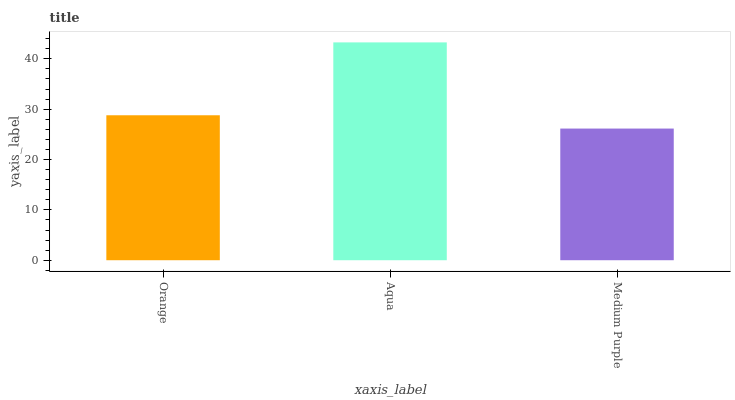Is Aqua the minimum?
Answer yes or no. No. Is Medium Purple the maximum?
Answer yes or no. No. Is Aqua greater than Medium Purple?
Answer yes or no. Yes. Is Medium Purple less than Aqua?
Answer yes or no. Yes. Is Medium Purple greater than Aqua?
Answer yes or no. No. Is Aqua less than Medium Purple?
Answer yes or no. No. Is Orange the high median?
Answer yes or no. Yes. Is Orange the low median?
Answer yes or no. Yes. Is Aqua the high median?
Answer yes or no. No. Is Aqua the low median?
Answer yes or no. No. 